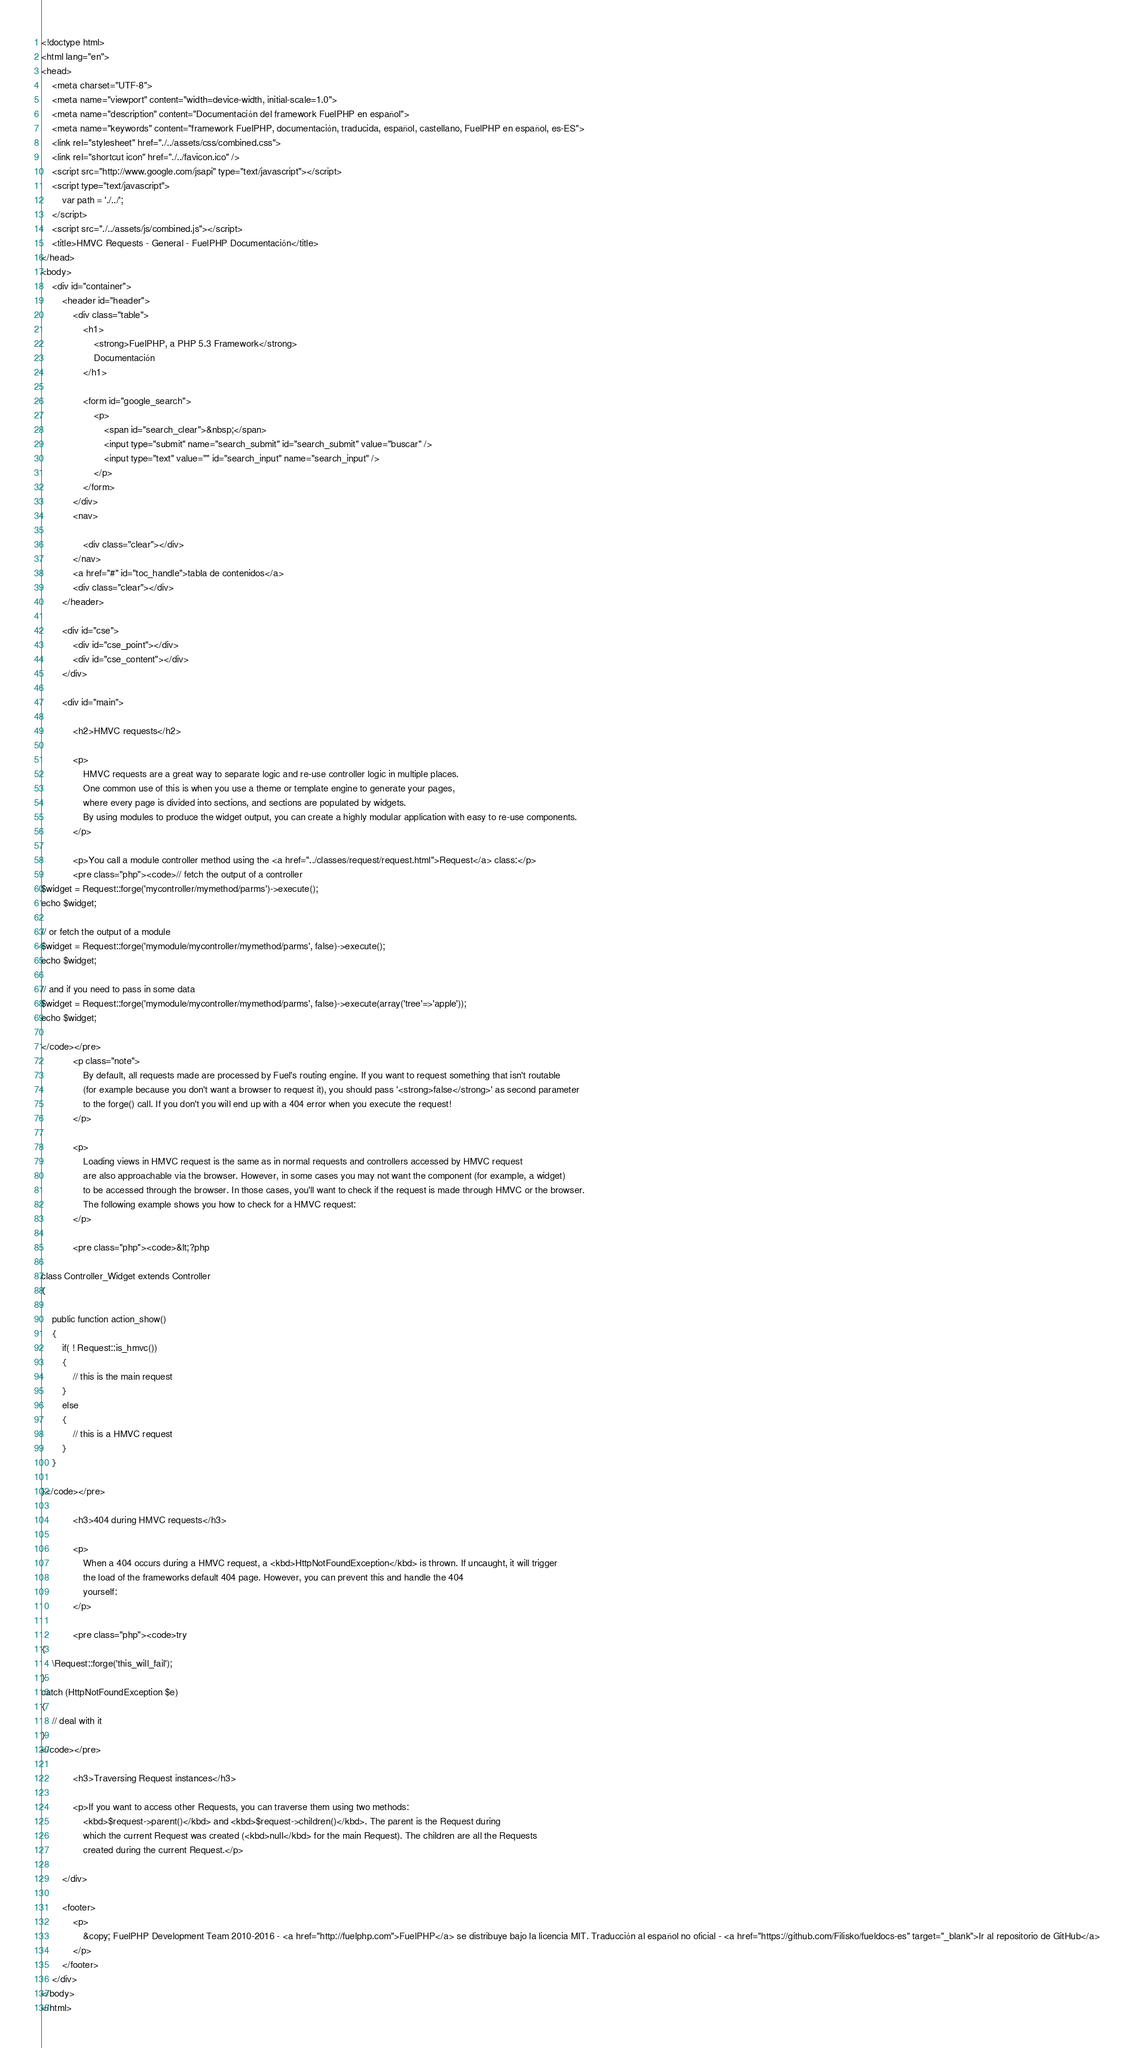Convert code to text. <code><loc_0><loc_0><loc_500><loc_500><_HTML_><!doctype html>
<html lang="en">
<head>
	<meta charset="UTF-8">
	<meta name="viewport" content="width=device-width, initial-scale=1.0">
	<meta name="description" content="Documentación del framework FuelPHP en español">
	<meta name="keywords" content="framework FuelPHP, documentación, traducida, español, castellano, FuelPHP en español, es-ES">
	<link rel="stylesheet" href="./../assets/css/combined.css">
	<link rel="shortcut icon" href="./../favicon.ico" />
	<script src="http://www.google.com/jsapi" type="text/javascript"></script>
	<script type="text/javascript">
		var path = './../';
	</script>
	<script src="./../assets/js/combined.js"></script>
	<title>HMVC Requests - General - FuelPHP Documentación</title>
</head>
<body>
	<div id="container">
		<header id="header">
			<div class="table">
				<h1>
					<strong>FuelPHP, a PHP 5.3 Framework</strong>
					Documentación
				</h1>

				<form id="google_search">
					<p>
						<span id="search_clear">&nbsp;</span>
						<input type="submit" name="search_submit" id="search_submit" value="buscar" />
						<input type="text" value="" id="search_input" name="search_input" />
					</p>
				</form>
			</div>
			<nav>

				<div class="clear"></div>
			</nav>
			<a href="#" id="toc_handle">tabla de contenidos</a>
			<div class="clear"></div>
		</header>

		<div id="cse">
			<div id="cse_point"></div>
			<div id="cse_content"></div>
		</div>

		<div id="main">

			<h2>HMVC requests</h2>

			<p>
				HMVC requests are a great way to separate logic and re-use controller logic in multiple places.
				One common use of this is when you use a theme or template engine to generate your pages,
				where every page is divided into sections, and sections are populated by widgets.
				By using modules to produce the widget output, you can create a highly modular application with easy to re-use components.
			</p>

			<p>You call a module controller method using the <a href="../classes/request/request.html">Request</a> class:</p>
			<pre class="php"><code>// fetch the output of a controller
$widget = Request::forge('mycontroller/mymethod/parms')->execute();
echo $widget;

// or fetch the output of a module
$widget = Request::forge('mymodule/mycontroller/mymethod/parms', false)->execute();
echo $widget;

// and if you need to pass in some data
$widget = Request::forge('mymodule/mycontroller/mymethod/parms', false)->execute(array('tree'=>'apple'));
echo $widget;

</code></pre>
			<p class="note">
				By default, all requests made are processed by Fuel's routing engine. If you want to request something that isn't routable
				(for example because you don't want a browser to request it), you should pass '<strong>false</strong>' as second parameter
				to the forge() call. If you don't you will end up with a 404 error when you execute the request!
			</p>

			<p>
				Loading views in HMVC request is the same as in normal requests and controllers accessed by HMVC request
				are also approachable via the browser. However, in some cases you may not want the component (for example, a widget)
				to be accessed through the browser. In those cases, you'll want to check if the request is made through HMVC or the browser.
				The following example shows you how to check for a HMVC request:
			</p>

			<pre class="php"><code>&lt;?php

class Controller_Widget extends Controller
{

	public function action_show()
	{
		if( ! Request::is_hmvc())
		{
			// this is the main request
		}
		else
		{
			// this is a HMVC request
		}
	}

}</code></pre>

			<h3>404 during HMVC requests</h3>

			<p>
				When a 404 occurs during a HMVC request, a <kbd>HttpNotFoundException</kbd> is thrown. If uncaught, it will trigger
				the load of the frameworks default 404 page. However, you can prevent this and handle the 404
				yourself:
			</p>

			<pre class="php"><code>try
{
	\Request::forge('this_will_fail');
}
catch (HttpNotFoundException $e)
{
	// deal with it
}
</code></pre>

			<h3>Traversing Request instances</h3>

			<p>If you want to access other Requests, you can traverse them using two methods:
				<kbd>$request->parent()</kbd> and <kbd>$request->children()</kbd>. The parent is the Request during
				which the current Request was created (<kbd>null</kbd> for the main Request). The children are all the Requests
				created during the current Request.</p>

		</div>

		<footer>
			<p>
				&copy; FuelPHP Development Team 2010-2016 - <a href="http://fuelphp.com">FuelPHP</a> se distribuye bajo la licencia MIT. Traducción al español no oficial - <a href="https://github.com/Filisko/fueldocs-es" target="_blank">Ir al repositorio de GitHub</a>
			</p>
		</footer>
	</div>
</body>
</html>
</code> 